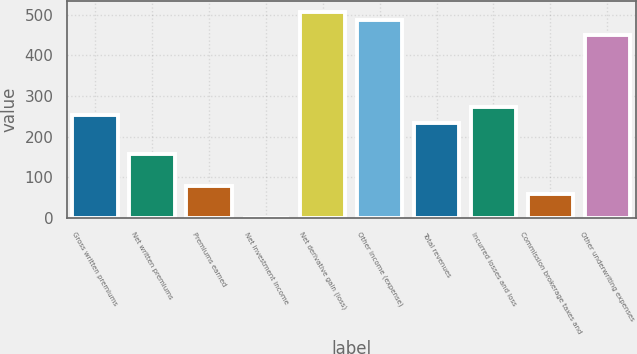Convert chart to OTSL. <chart><loc_0><loc_0><loc_500><loc_500><bar_chart><fcel>Gross written premiums<fcel>Net written premiums<fcel>Premiums earned<fcel>Net investment income<fcel>Net derivative gain (loss)<fcel>Other income (expense)<fcel>Total revenues<fcel>Incurred losses and loss<fcel>Commission brokerage taxes and<fcel>Other underwriting expenses<nl><fcel>253.73<fcel>156.18<fcel>78.14<fcel>0.1<fcel>507.36<fcel>487.85<fcel>234.22<fcel>273.24<fcel>58.63<fcel>448.83<nl></chart> 